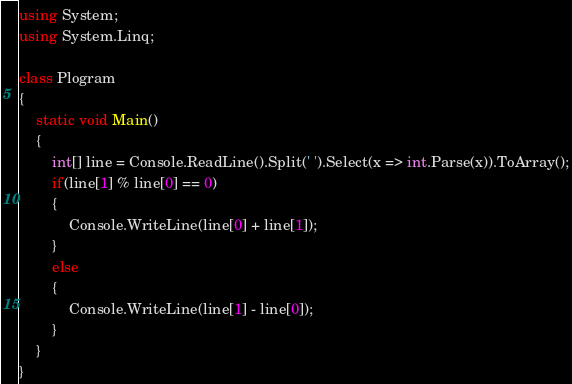<code> <loc_0><loc_0><loc_500><loc_500><_C#_>using System;
using System.Linq;

class Plogram
{
    static void Main()
    {
        int[] line = Console.ReadLine().Split(' ').Select(x => int.Parse(x)).ToArray();
        if(line[1] % line[0] == 0)
        {
            Console.WriteLine(line[0] + line[1]);
        }
        else
        {
            Console.WriteLine(line[1] - line[0]);
        }
    }
}</code> 